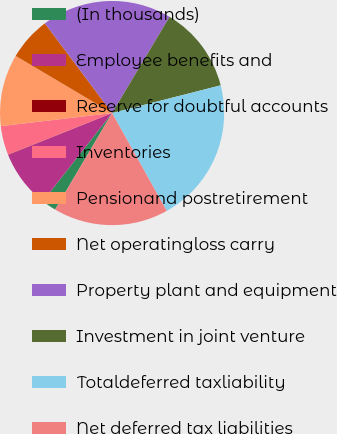Convert chart to OTSL. <chart><loc_0><loc_0><loc_500><loc_500><pie_chart><fcel>(In thousands)<fcel>Employee benefits and<fcel>Reserve for doubtful accounts<fcel>Inventories<fcel>Pensionand postretirement<fcel>Net operatingloss carry<fcel>Property plant and equipment<fcel>Investment in joint venture<fcel>Totaldeferred taxliability<fcel>Net deferred tax liabilities<nl><fcel>2.11%<fcel>8.31%<fcel>0.05%<fcel>4.18%<fcel>10.38%<fcel>6.25%<fcel>18.8%<fcel>12.45%<fcel>20.87%<fcel>16.59%<nl></chart> 